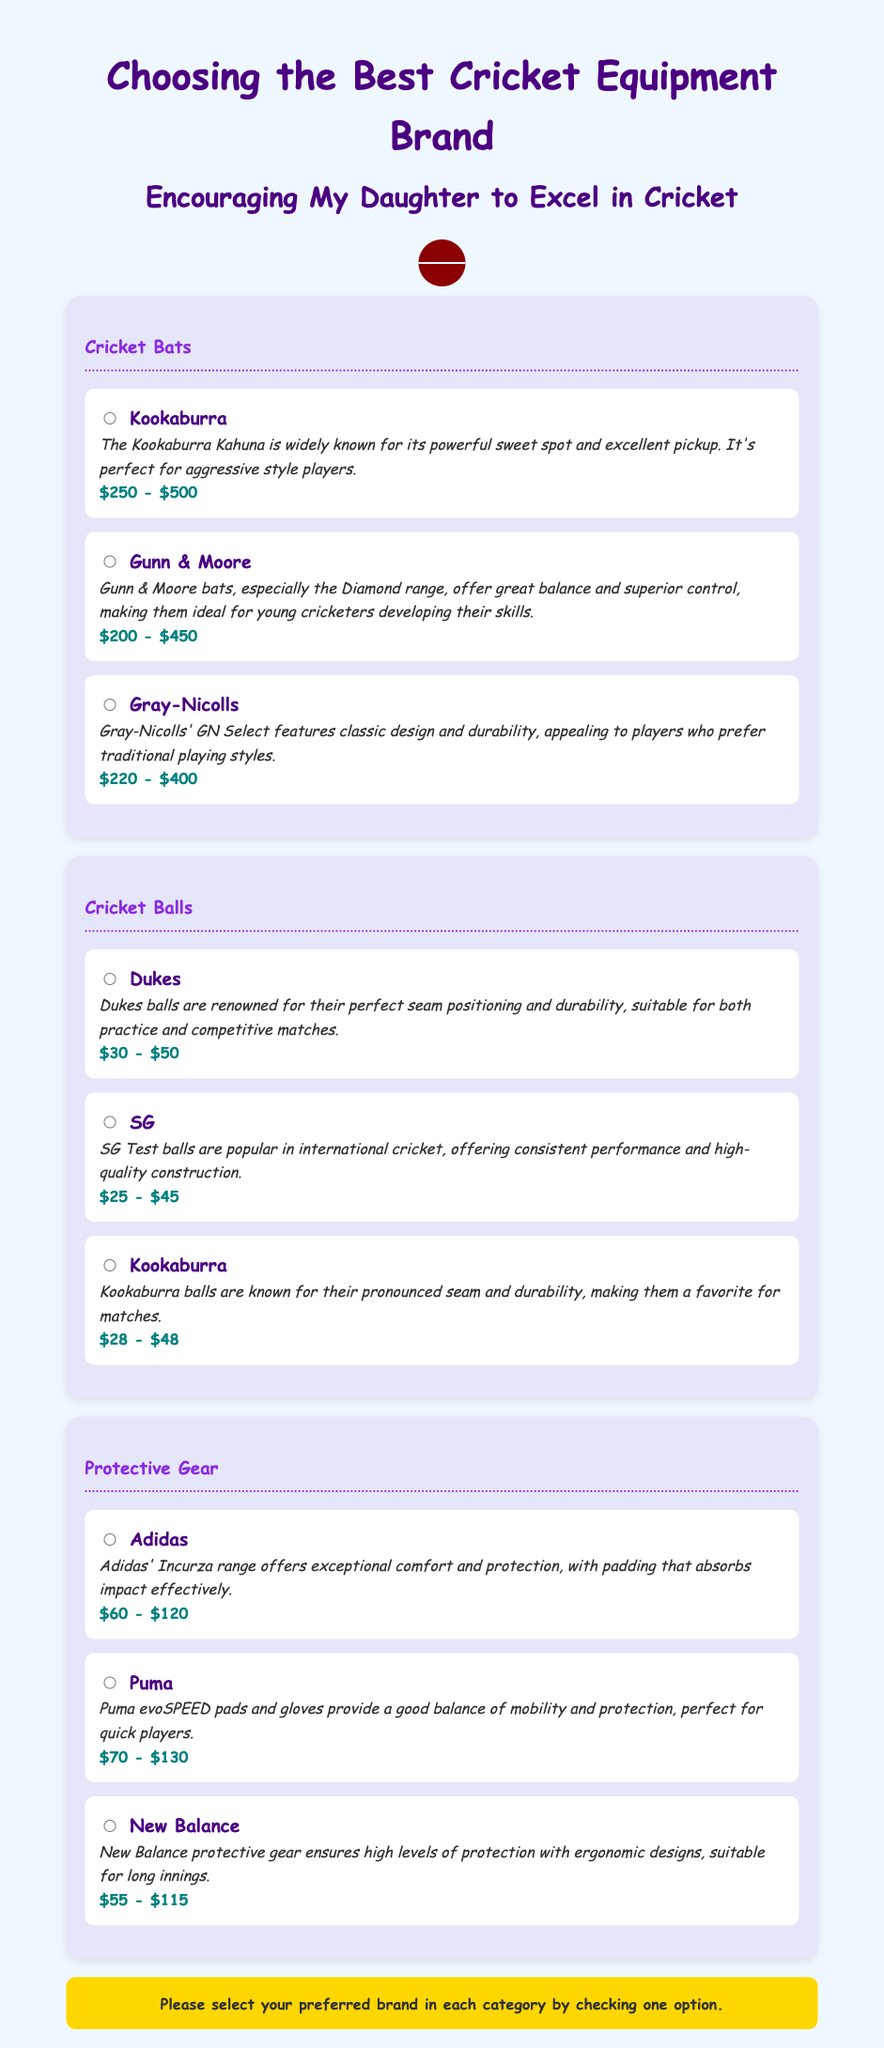What is the price range for Kookaburra bats? The price range for Kookaburra bats is mentioned in the document as $250 - $500.
Answer: $250 - $500 Which brand of cricket balls is renowned for perfect seam positioning? The document states that Dukes balls are renowned for their perfect seam positioning and durability.
Answer: Dukes What protective gear brand offers exceptional comfort and protection? Adidas' Incurza range is highlighted for offering exceptional comfort and protection in the document.
Answer: Adidas What is the review for Gunn & Moore bats? The document includes a review stating that Gunn & Moore bats offer great balance and superior control, ideal for young cricketers.
Answer: Great balance and superior control Which brand of protective gear is priced between $70 - $130? Puma is the brand of protective gear that has a price range specified as $70 - $130 in the document.
Answer: Puma What cricket ball brand is priced between $25 - $45? The document lists SG as the brand of cricket balls priced between $25 - $45.
Answer: SG Which cricket bat brand features a classic design? Gray-Nicolls is mentioned in the document as a brand that features a classic design in its GN Select bats.
Answer: Gray-Nicolls How many brands are listed for cricket bats? The document includes three brands for cricket bats: Kookaburra, Gunn & Moore, and Gray-Nicolls.
Answer: Three 